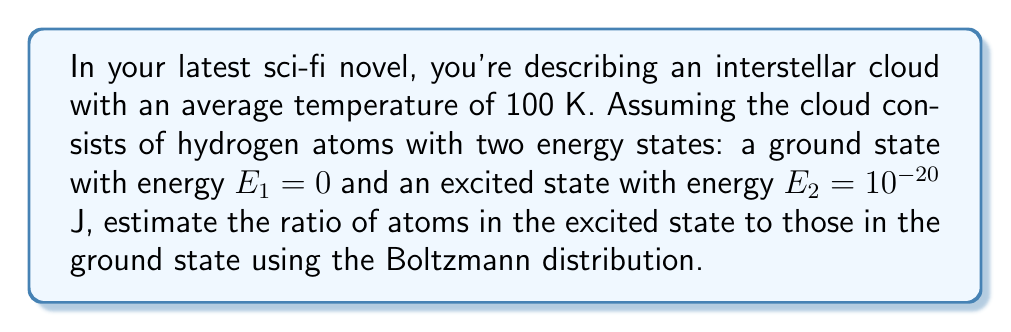Provide a solution to this math problem. To solve this problem, we'll use the Boltzmann distribution formula and follow these steps:

1) The Boltzmann distribution gives the probability of finding a particle in a state with energy $E_i$:

   $$P_i \propto e^{-E_i / (k_B T)}$$

   where $k_B$ is the Boltzmann constant and $T$ is the temperature.

2) The ratio of probabilities for two states is:

   $$\frac{P_2}{P_1} = \frac{e^{-E_2 / (k_B T)}}{e^{-E_1 / (k_B T)}}$$

3) Given:
   - $E_1 = 0$ J (ground state)
   - $E_2 = 10^{-20}$ J (excited state)
   - $T = 100$ K
   - $k_B = 1.380649 \times 10^{-23}$ J/K (Boltzmann constant)

4) Substituting these values:

   $$\frac{P_2}{P_1} = \frac{e^{-10^{-20} / (1.380649 \times 10^{-23} \times 100)}}{e^{0}} = e^{-7.243}$$

5) Calculate the exponent:
   $-7.243$

6) Evaluate the exponential:
   $e^{-7.243} \approx 0.0007153$

Therefore, the ratio of atoms in the excited state to those in the ground state is approximately 0.0007153 or about 1 in 1,397.
Answer: $0.0007153$ 